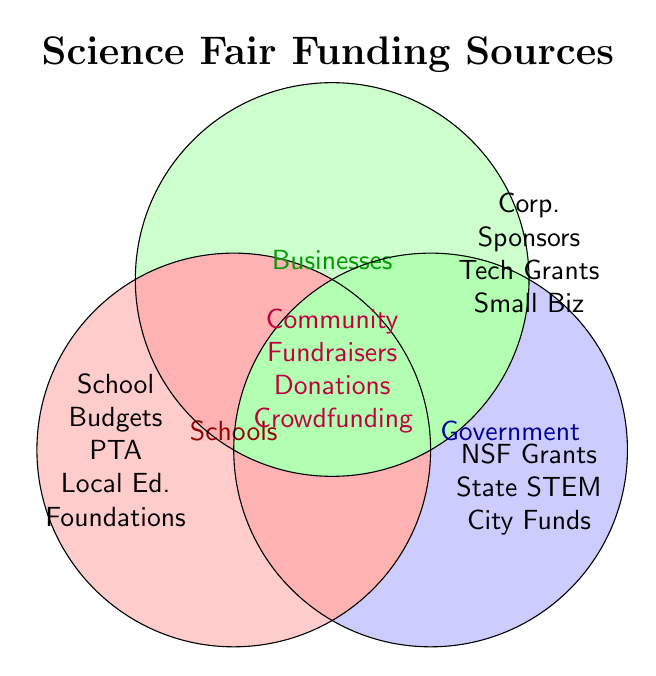What are the three funding categories in the diagram? The diagram displays three main circles, each representing a funding category labeled as "Schools," "Businesses," and "Government."
Answer: Schools, Businesses, Government Which funding source appears in all categories? The center overlap area of all three circles contains sources labeled as "Community Fundraisers," "Individual Donations," and "Online Crowdfunding," indicating they appear in all three categories.
Answer: Community Fundraisers, Individual Donations, Online Crowdfunding Name a funding source exclusive to government. The section of the diagram exclusively within the "Government" circle lists "NSF Outreach Grants," "State STEM Initiatives," and "City Parks & Recreation Funds."
Answer: NSF Outreach Grants, State STEM Initiatives, City Parks & Recreation Funds Which funding category overlaps with both Schools and Businesses but not Government? There is no section exclusively overlapping with Schools and Businesses only. The overlapping areas either include Government or none at all.
Answer: None Identify sources of funding specific to Schools. The area solely within the Schools circle lists "School Budgets," "PTA Contributions," and "Local Education Foundations."
Answer: School Budgets, PTA Contributions, Local Education Foundations Compare the number of funding sources specified for Businesses and Government. Which has more? Businesses have "Corporate Sponsorships," "Tech Company Grants," and "Local Small Business Donations" (3 sources), whereas Government has "NSF Outreach Grants," "State STEM Initiatives," and "City Parks & Recreation Funds" (3 sources). Both have the same number of sources.
Answer: Equal How many funding sources are shared among all categories and name them. The middle section where all three circles overlap lists three sources, which are "Community Fundraisers," "Individual Donations," and "Online Crowdfunding."
Answer: Three: Community Fundraisers, Individual Donations, Online Crowdfunding List the shared funding sources between Schools and Government only. There is no specific section in the diagram showing an exclusive overlap between Schools and Government only, so there are no shared sources exclusively between these two categories.
Answer: None Which category has contributions from tech companies? The diagram shows "Tech Company Grants" listed exclusively within the "Businesses" circle, indicating it's a funding source for Businesses.
Answer: Businesses Explain why "PTA Contributions" wouldn't be found in the Businesses category. "PTA Contributions" are listed exclusively within the Schools circle, indicating they are specific to Schools' funding. PTAs are associated with schools' parent-teacher associations, not businesses.
Answer: Specific to Schools 